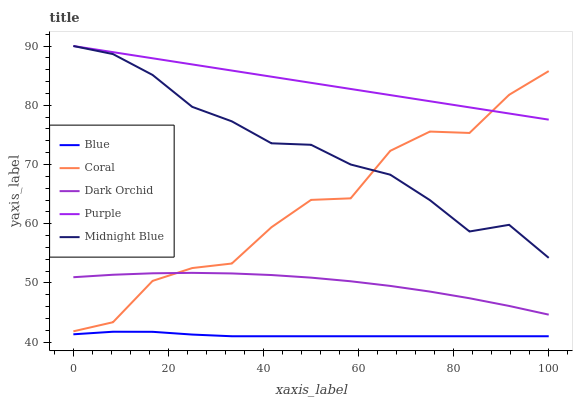Does Blue have the minimum area under the curve?
Answer yes or no. Yes. Does Purple have the maximum area under the curve?
Answer yes or no. Yes. Does Coral have the minimum area under the curve?
Answer yes or no. No. Does Coral have the maximum area under the curve?
Answer yes or no. No. Is Purple the smoothest?
Answer yes or no. Yes. Is Coral the roughest?
Answer yes or no. Yes. Is Coral the smoothest?
Answer yes or no. No. Is Purple the roughest?
Answer yes or no. No. Does Coral have the lowest value?
Answer yes or no. No. Does Coral have the highest value?
Answer yes or no. No. Is Blue less than Coral?
Answer yes or no. Yes. Is Coral greater than Blue?
Answer yes or no. Yes. Does Blue intersect Coral?
Answer yes or no. No. 